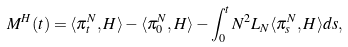Convert formula to latex. <formula><loc_0><loc_0><loc_500><loc_500>M ^ { H } ( t ) = \langle \pi ^ { N } _ { t } , H \rangle - \langle \pi ^ { N } _ { 0 } , H \rangle - \int ^ { t } _ { 0 } N ^ { 2 } L _ { N } \langle \pi ^ { N } _ { s } , H \rangle d s ,</formula> 